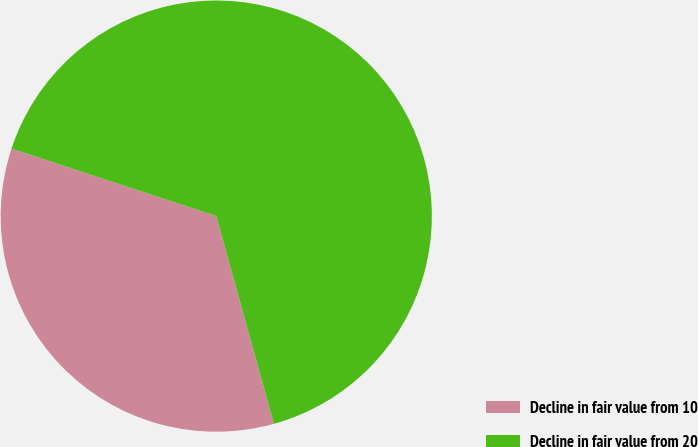Convert chart to OTSL. <chart><loc_0><loc_0><loc_500><loc_500><pie_chart><fcel>Decline in fair value from 10<fcel>Decline in fair value from 20<nl><fcel>34.38%<fcel>65.62%<nl></chart> 